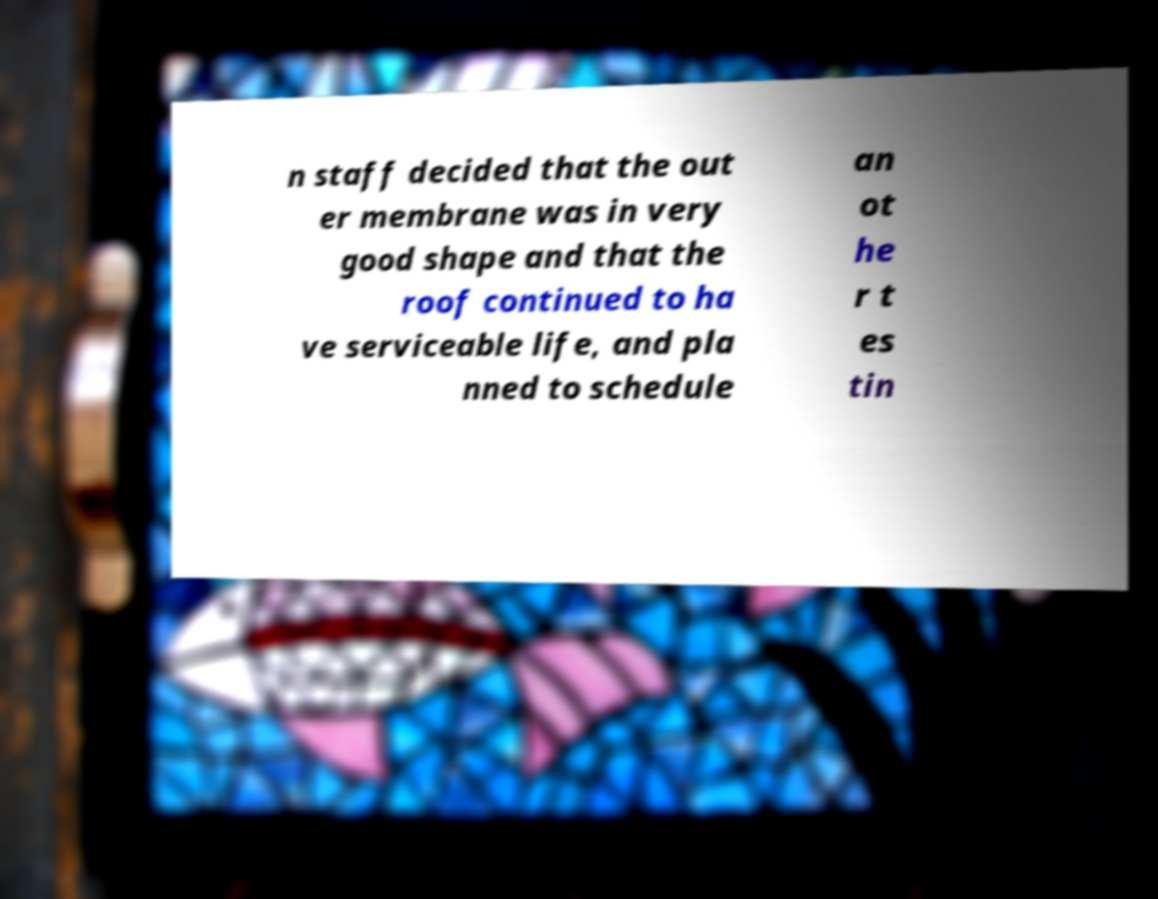There's text embedded in this image that I need extracted. Can you transcribe it verbatim? n staff decided that the out er membrane was in very good shape and that the roof continued to ha ve serviceable life, and pla nned to schedule an ot he r t es tin 